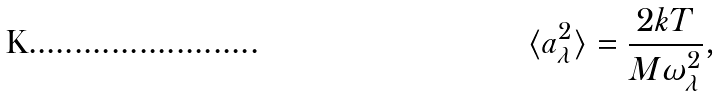<formula> <loc_0><loc_0><loc_500><loc_500>\langle a _ { \lambda } ^ { 2 } \rangle = \frac { 2 k T } { M \omega _ { \lambda } ^ { 2 } } ,</formula> 